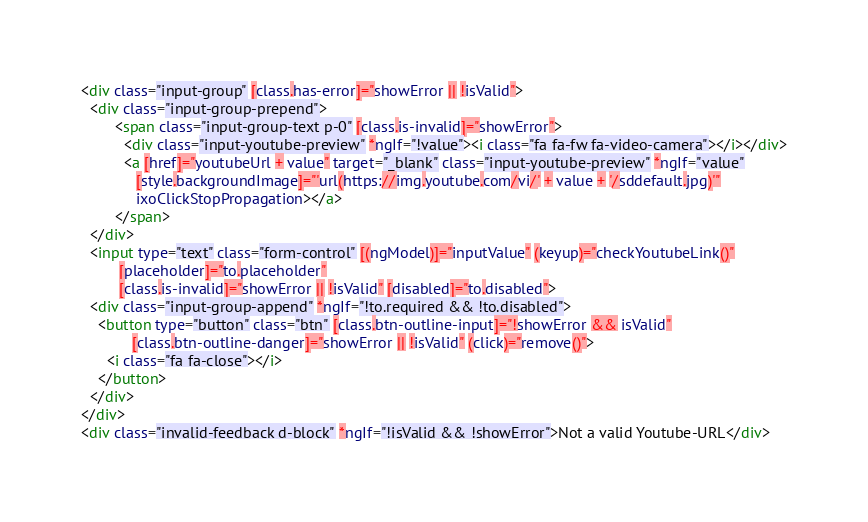<code> <loc_0><loc_0><loc_500><loc_500><_HTML_><div class="input-group" [class.has-error]="showError || !isValid">
  <div class="input-group-prepend">
        <span class="input-group-text p-0" [class.is-invalid]="showError">
          <div class="input-youtube-preview" *ngIf="!value"><i class="fa fa-fw fa-video-camera"></i></div>
          <a [href]="youtubeUrl + value" target="_blank" class="input-youtube-preview" *ngIf="value"
             [style.backgroundImage]="'url(https://img.youtube.com/vi/' + value + '/sddefault.jpg)'"
             ixoClickStopPropagation></a>
        </span>
  </div>
  <input type="text" class="form-control" [(ngModel)]="inputValue" (keyup)="checkYoutubeLink()"
         [placeholder]="to.placeholder"
         [class.is-invalid]="showError || !isValid" [disabled]="to.disabled">
  <div class="input-group-append" *ngIf="!to.required && !to.disabled">
    <button type="button" class="btn" [class.btn-outline-input]="!showError && isValid"
            [class.btn-outline-danger]="showError || !isValid" (click)="remove()">
      <i class="fa fa-close"></i>
    </button>
  </div>
</div>
<div class="invalid-feedback d-block" *ngIf="!isValid && !showError">Not a valid Youtube-URL</div>
</code> 